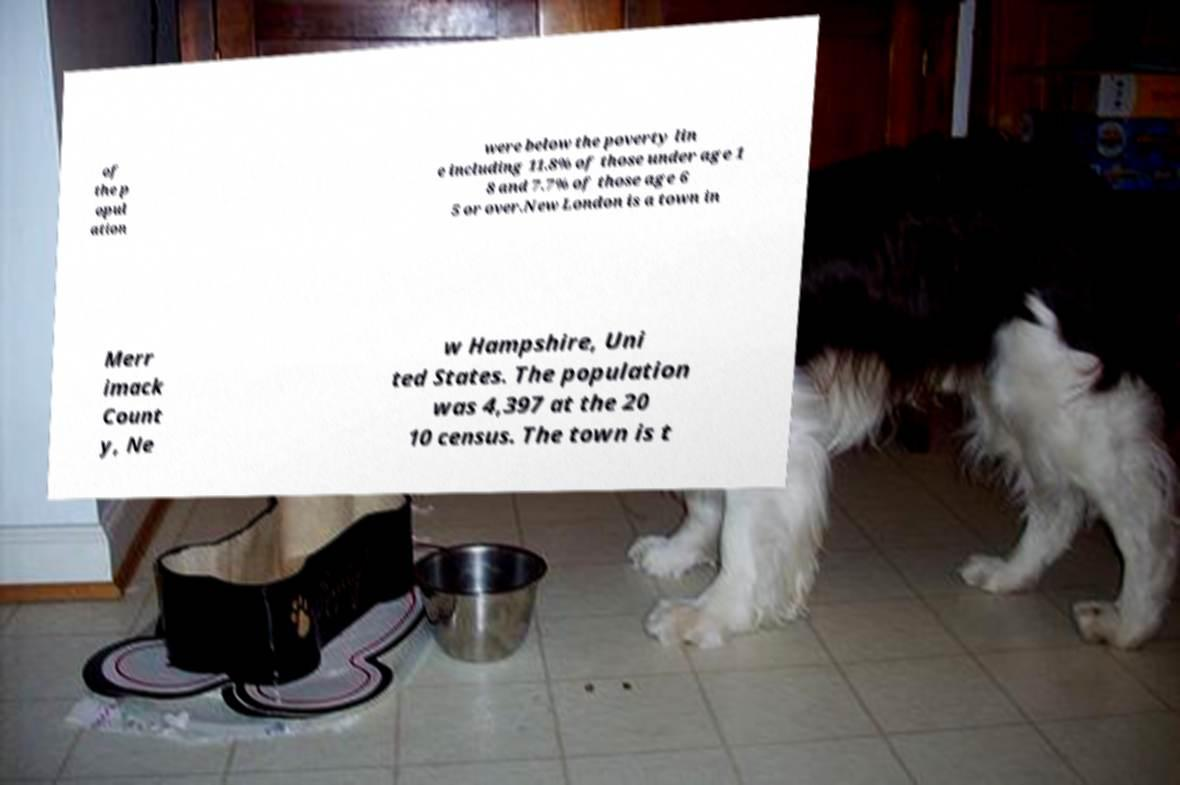Please read and relay the text visible in this image. What does it say? of the p opul ation were below the poverty lin e including 11.8% of those under age 1 8 and 7.7% of those age 6 5 or over.New London is a town in Merr imack Count y, Ne w Hampshire, Uni ted States. The population was 4,397 at the 20 10 census. The town is t 